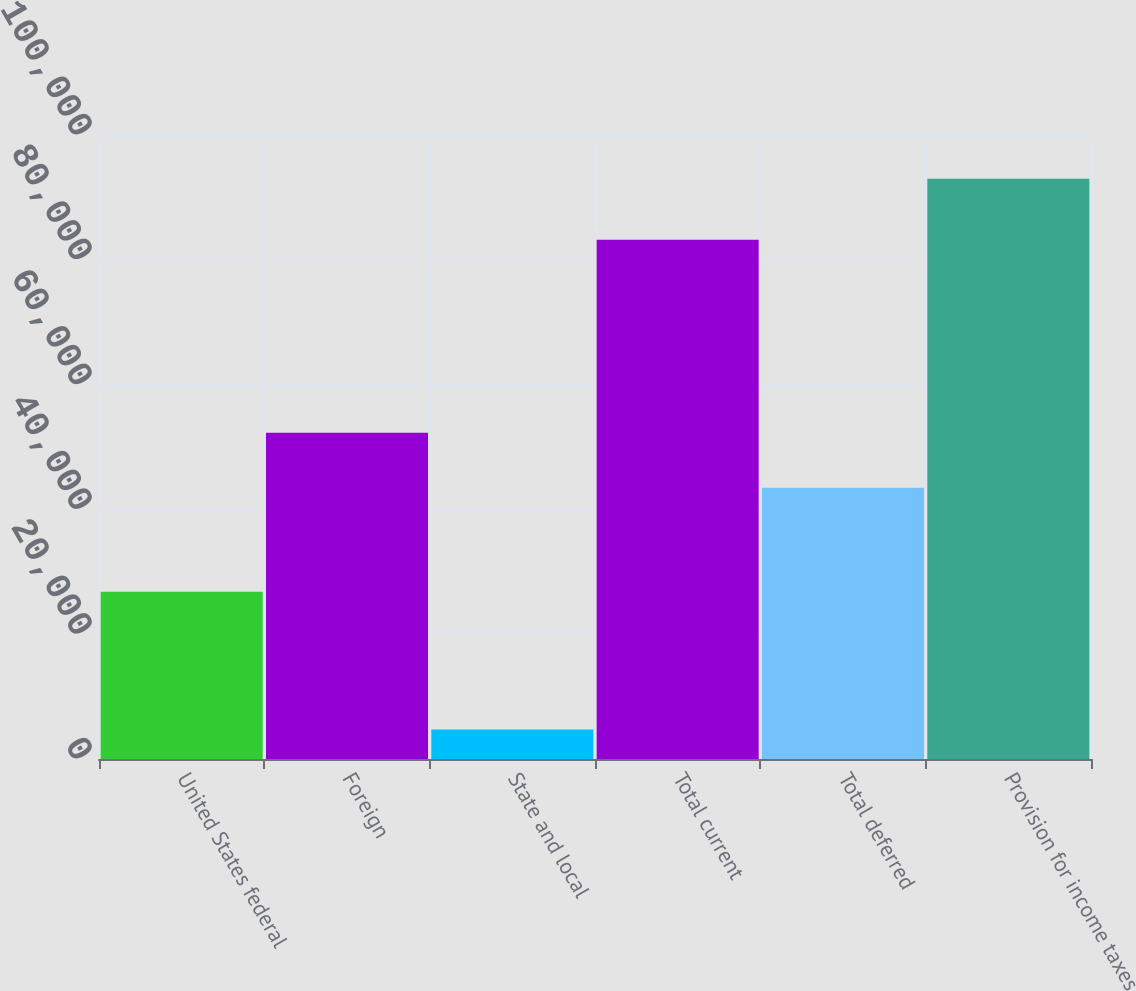Convert chart to OTSL. <chart><loc_0><loc_0><loc_500><loc_500><bar_chart><fcel>United States federal<fcel>Foreign<fcel>State and local<fcel>Total current<fcel>Total deferred<fcel>Provision for income taxes<nl><fcel>26822<fcel>52287.8<fcel>4713<fcel>83219<fcel>43461<fcel>92981<nl></chart> 